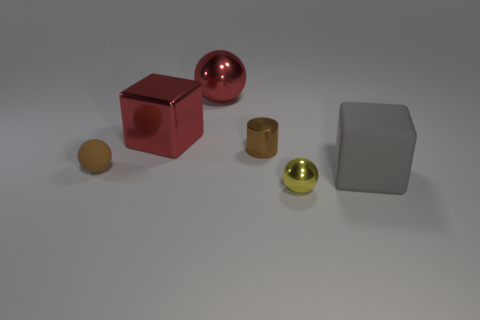Subtract all tiny brown balls. How many balls are left? 2 Subtract all brown spheres. How many spheres are left? 2 Add 2 yellow balls. How many objects exist? 8 Subtract all cylinders. How many objects are left? 5 Subtract 3 balls. How many balls are left? 0 Subtract all gray blocks. Subtract all red spheres. How many blocks are left? 1 Subtract all brown spheres. How many yellow cylinders are left? 0 Subtract all small green cylinders. Subtract all tiny things. How many objects are left? 3 Add 3 tiny metallic things. How many tiny metallic things are left? 5 Add 2 small green shiny cylinders. How many small green shiny cylinders exist? 2 